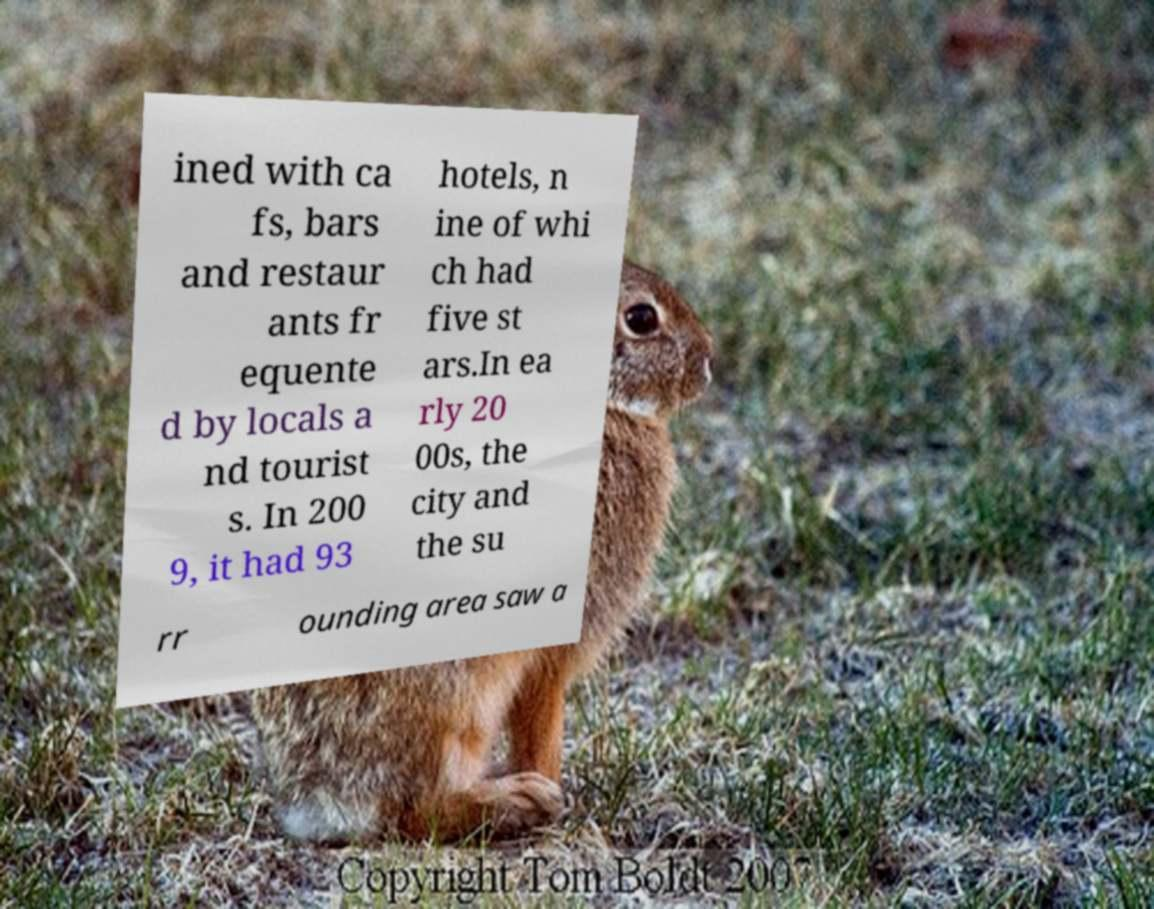Please read and relay the text visible in this image. What does it say? ined with ca fs, bars and restaur ants fr equente d by locals a nd tourist s. In 200 9, it had 93 hotels, n ine of whi ch had five st ars.In ea rly 20 00s, the city and the su rr ounding area saw a 